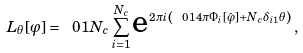<formula> <loc_0><loc_0><loc_500><loc_500>L _ { \theta } [ \varphi ] = \ 0 { 1 } { N _ { c } } \sum _ { i = 1 } ^ { N _ { c } } \text {e} ^ { 2 \pi i \left ( \ 0 { 1 } { 4 \pi } \Phi _ { i } [ \hat { \varphi } ] + N _ { c } \delta _ { i 1 } \theta \right ) } \, ,</formula> 